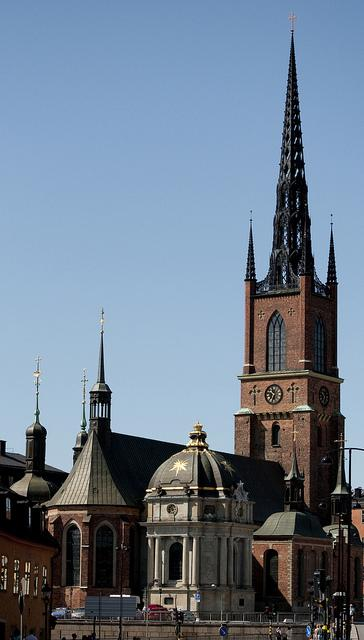What design is next to the clock on the largest building?

Choices:
A) star
B) wolf sigil
C) cross
D) hexagon cross 